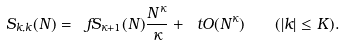Convert formula to latex. <formula><loc_0><loc_0><loc_500><loc_500>S _ { k , k } ( N ) = \ f S _ { \kappa + 1 } ( N ) \frac { N ^ { \kappa } } { \kappa } + \ t O ( N ^ { \kappa } ) \quad ( | k | \leq K ) .</formula> 